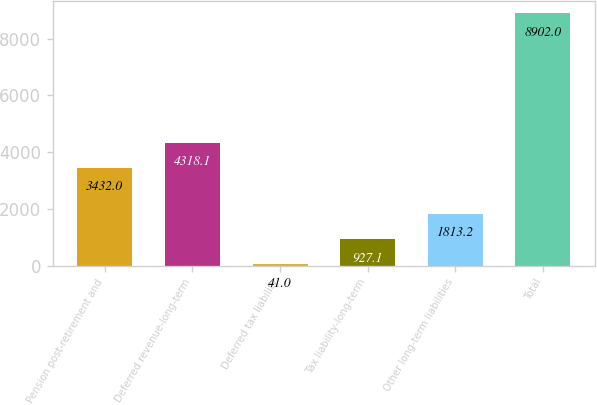<chart> <loc_0><loc_0><loc_500><loc_500><bar_chart><fcel>Pension post-retirement and<fcel>Deferred revenue-long-term<fcel>Deferred tax liability<fcel>Tax liability-long-term<fcel>Other long-term liabilities<fcel>Total<nl><fcel>3432<fcel>4318.1<fcel>41<fcel>927.1<fcel>1813.2<fcel>8902<nl></chart> 